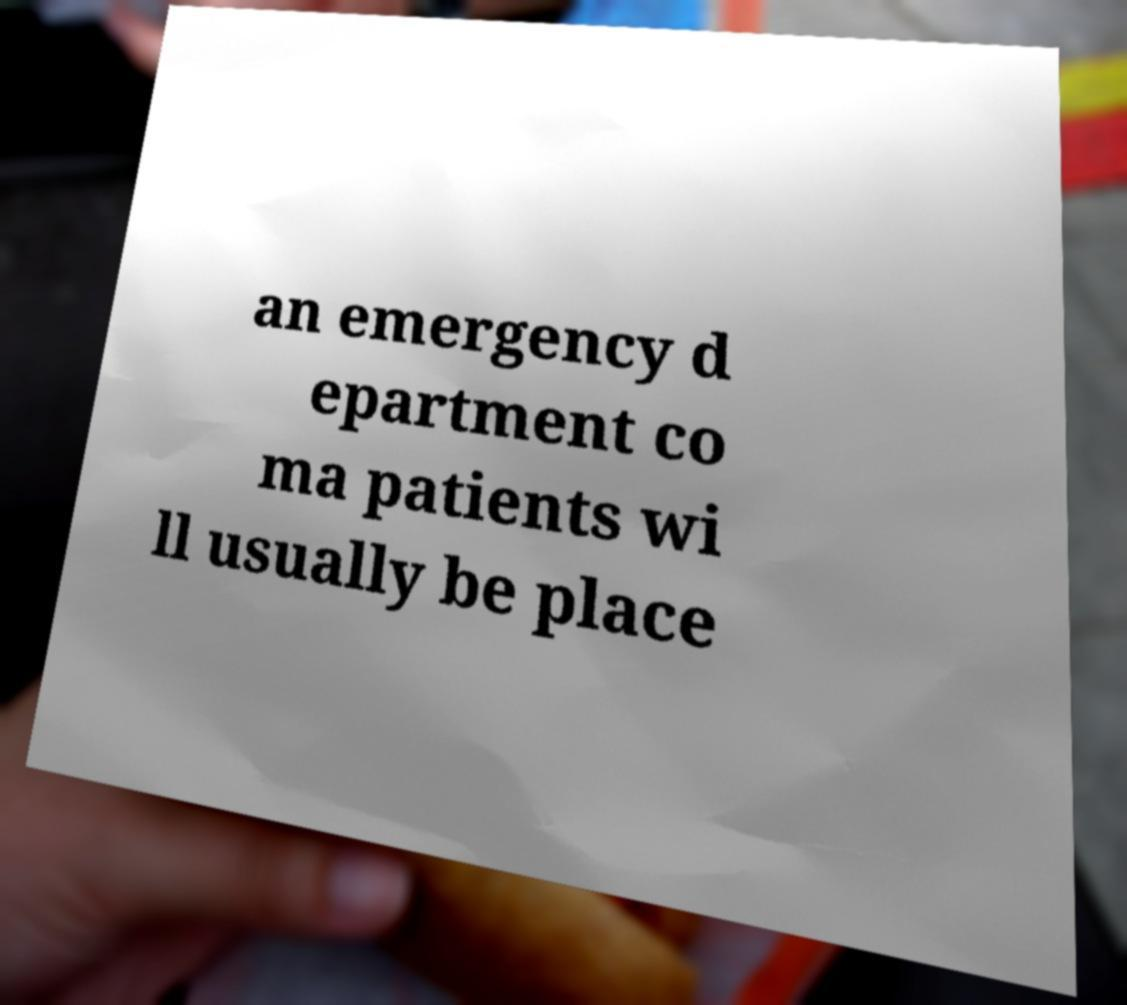Can you read and provide the text displayed in the image?This photo seems to have some interesting text. Can you extract and type it out for me? an emergency d epartment co ma patients wi ll usually be place 